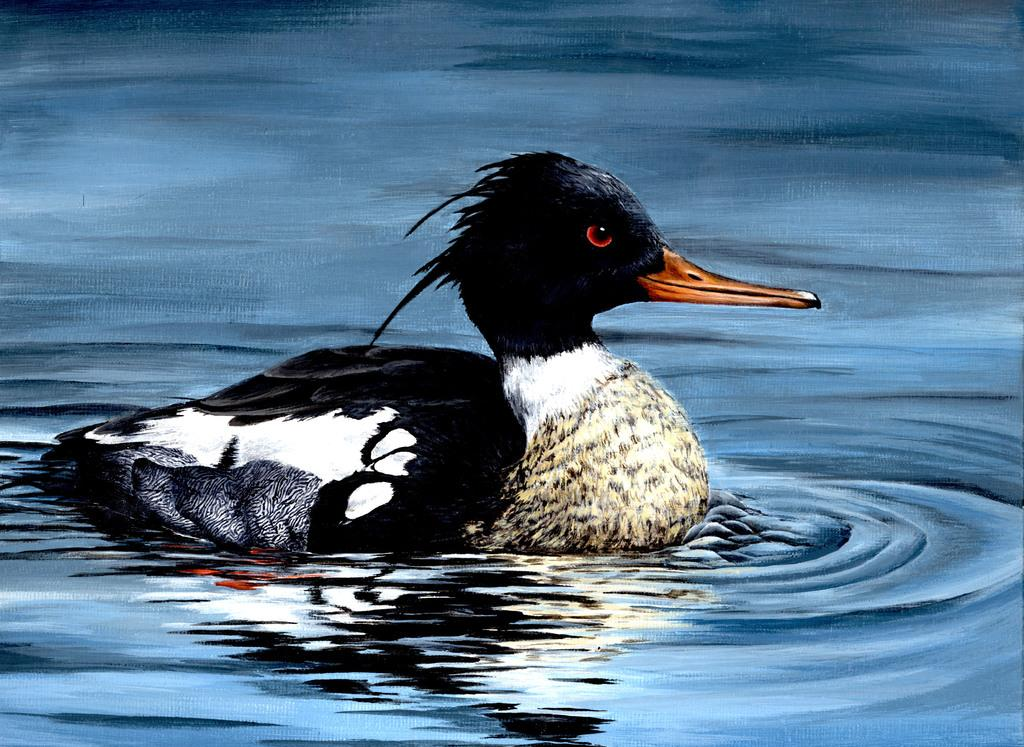What type of artwork is shown in the image? The image appears to be a painting. What animal can be seen in the painting? There is a duck in the water. What color is the water depicted as in the painting? The water is depicted as blue in color. How many bikes are parked on the stage in the image? There are no bikes or stage present in the image; it features a painting of a duck in blue water. 